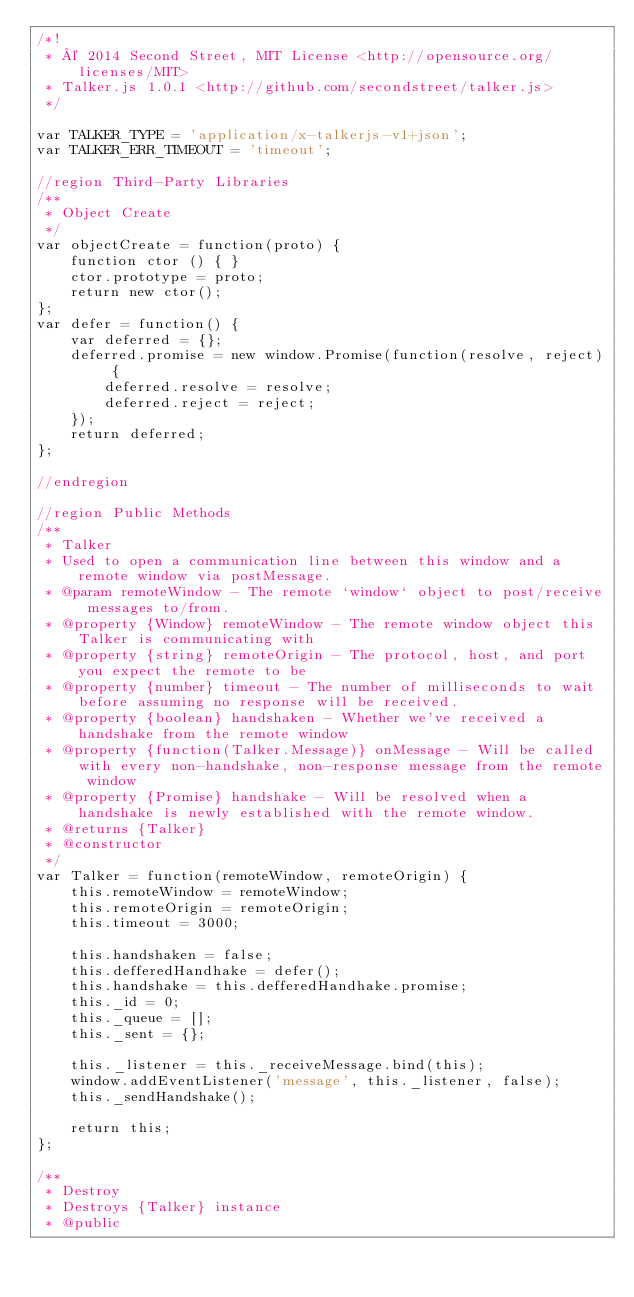Convert code to text. <code><loc_0><loc_0><loc_500><loc_500><_JavaScript_>/*!
 * © 2014 Second Street, MIT License <http://opensource.org/licenses/MIT>
 * Talker.js 1.0.1 <http://github.com/secondstreet/talker.js>
 */

var TALKER_TYPE = 'application/x-talkerjs-v1+json';
var TALKER_ERR_TIMEOUT = 'timeout';

//region Third-Party Libraries
/**
 * Object Create
 */
var objectCreate = function(proto) {
    function ctor () { }
    ctor.prototype = proto;
    return new ctor();
};
var defer = function() {
    var deferred = {};
    deferred.promise = new window.Promise(function(resolve, reject) {
        deferred.resolve = resolve;
        deferred.reject = reject;
    });
    return deferred;
};

//endregion

//region Public Methods
/**
 * Talker
 * Used to open a communication line between this window and a remote window via postMessage.
 * @param remoteWindow - The remote `window` object to post/receive messages to/from.
 * @property {Window} remoteWindow - The remote window object this Talker is communicating with
 * @property {string} remoteOrigin - The protocol, host, and port you expect the remote to be
 * @property {number} timeout - The number of milliseconds to wait before assuming no response will be received.
 * @property {boolean} handshaken - Whether we've received a handshake from the remote window
 * @property {function(Talker.Message)} onMessage - Will be called with every non-handshake, non-response message from the remote window
 * @property {Promise} handshake - Will be resolved when a handshake is newly established with the remote window.
 * @returns {Talker}
 * @constructor
 */
var Talker = function(remoteWindow, remoteOrigin) {
    this.remoteWindow = remoteWindow;
    this.remoteOrigin = remoteOrigin;
    this.timeout = 3000;

    this.handshaken = false;
    this.defferedHandhake = defer();
    this.handshake = this.defferedHandhake.promise;
    this._id = 0;
    this._queue = [];
    this._sent = {};

    this._listener = this._receiveMessage.bind(this);
    window.addEventListener('message', this._listener, false);
    this._sendHandshake();

    return this;
};

/**
 * Destroy
 * Destroys {Talker} instance
 * @public</code> 